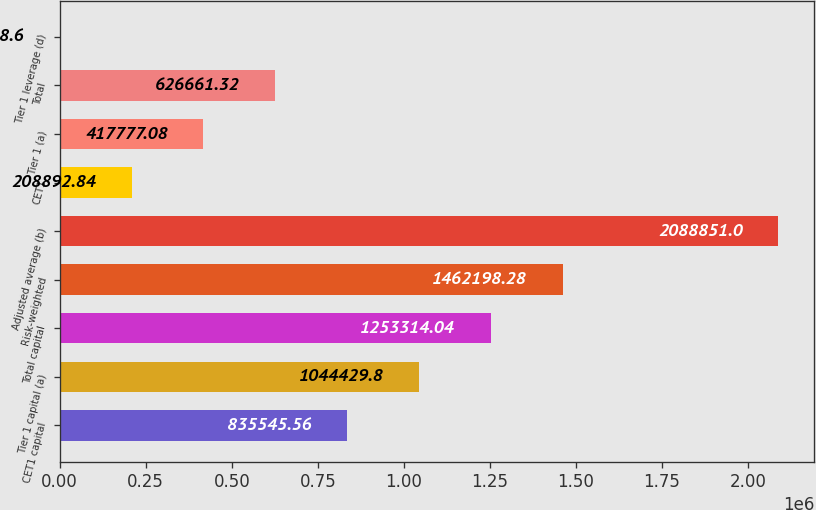Convert chart to OTSL. <chart><loc_0><loc_0><loc_500><loc_500><bar_chart><fcel>CET1 capital<fcel>Tier 1 capital (a)<fcel>Total capital<fcel>Risk-weighted<fcel>Adjusted average (b)<fcel>CET1<fcel>Tier 1 (a)<fcel>Total<fcel>Tier 1 leverage (d)<nl><fcel>835546<fcel>1.04443e+06<fcel>1.25331e+06<fcel>1.4622e+06<fcel>2.08885e+06<fcel>208893<fcel>417777<fcel>626661<fcel>8.6<nl></chart> 